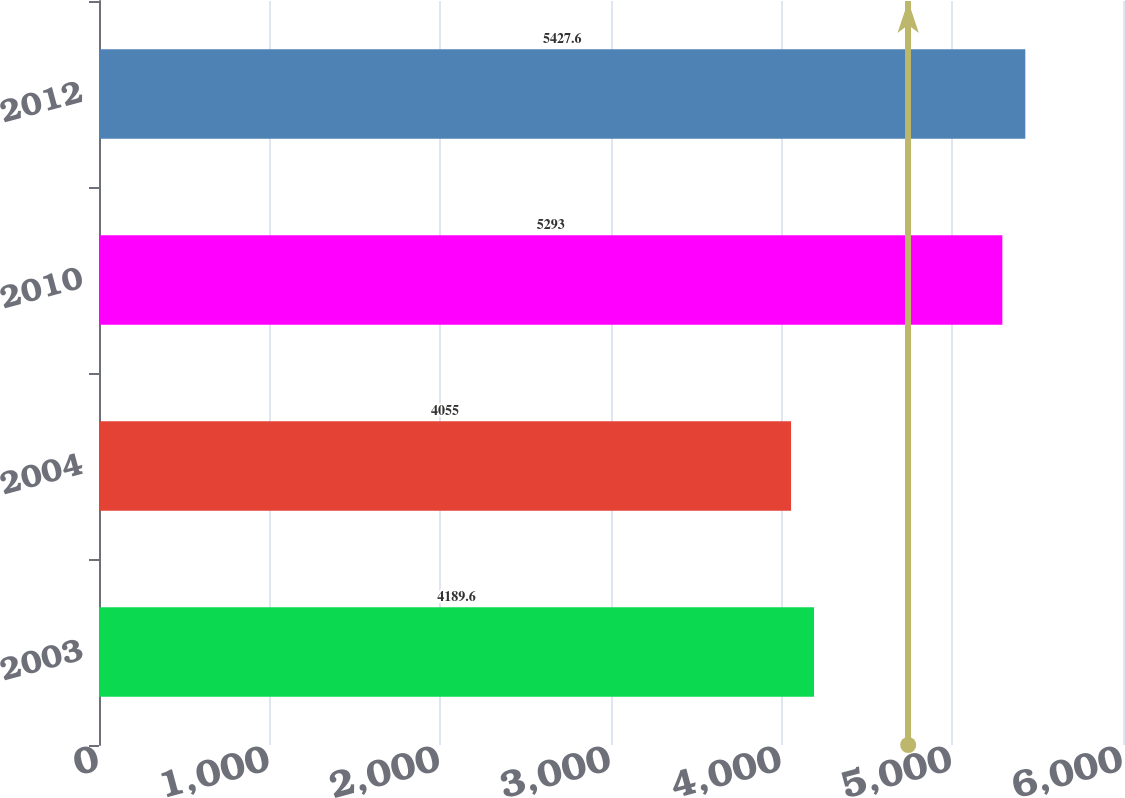Convert chart to OTSL. <chart><loc_0><loc_0><loc_500><loc_500><bar_chart><fcel>2003<fcel>2004<fcel>2010<fcel>2012<nl><fcel>4189.6<fcel>4055<fcel>5293<fcel>5427.6<nl></chart> 